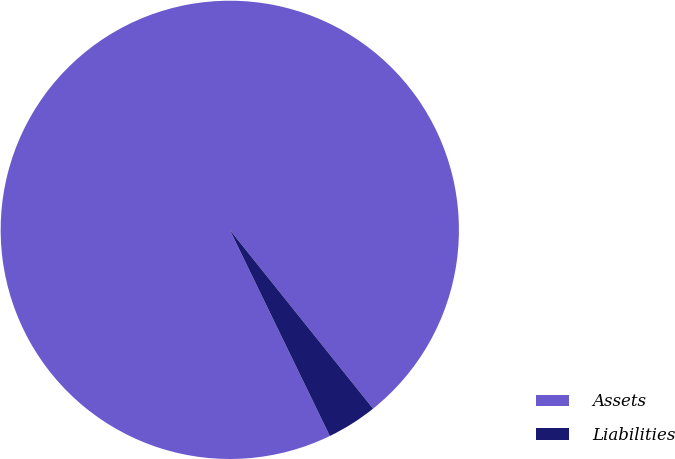<chart> <loc_0><loc_0><loc_500><loc_500><pie_chart><fcel>Assets<fcel>Liabilities<nl><fcel>96.44%<fcel>3.56%<nl></chart> 